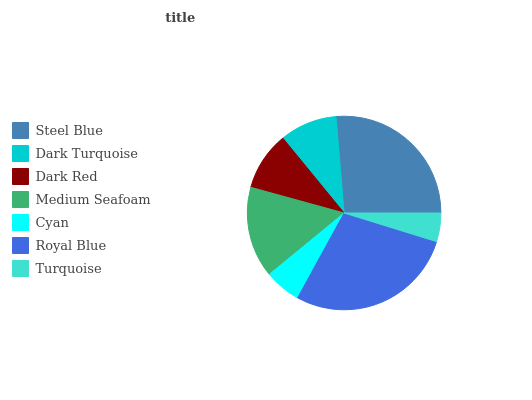Is Turquoise the minimum?
Answer yes or no. Yes. Is Royal Blue the maximum?
Answer yes or no. Yes. Is Dark Turquoise the minimum?
Answer yes or no. No. Is Dark Turquoise the maximum?
Answer yes or no. No. Is Steel Blue greater than Dark Turquoise?
Answer yes or no. Yes. Is Dark Turquoise less than Steel Blue?
Answer yes or no. Yes. Is Dark Turquoise greater than Steel Blue?
Answer yes or no. No. Is Steel Blue less than Dark Turquoise?
Answer yes or no. No. Is Dark Red the high median?
Answer yes or no. Yes. Is Dark Red the low median?
Answer yes or no. Yes. Is Turquoise the high median?
Answer yes or no. No. Is Turquoise the low median?
Answer yes or no. No. 